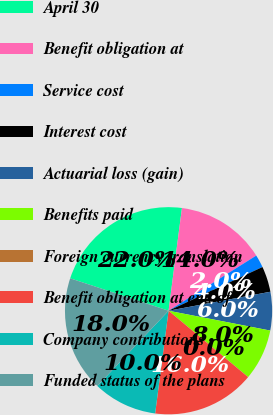Convert chart. <chart><loc_0><loc_0><loc_500><loc_500><pie_chart><fcel>April 30<fcel>Benefit obligation at<fcel>Service cost<fcel>Interest cost<fcel>Actuarial loss (gain)<fcel>Benefits paid<fcel>Foreign currency translation<fcel>Benefit obligation at end of<fcel>Company contributions<fcel>Funded status of the plans<nl><fcel>22.0%<fcel>14.0%<fcel>2.0%<fcel>4.0%<fcel>6.0%<fcel>8.0%<fcel>0.0%<fcel>16.0%<fcel>10.0%<fcel>18.0%<nl></chart> 